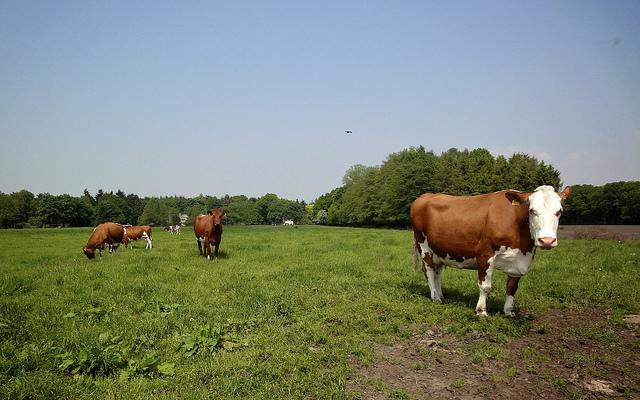How many cows are looking at the camera? Please explain your reasoning. two. Only two are the rest are eating. 